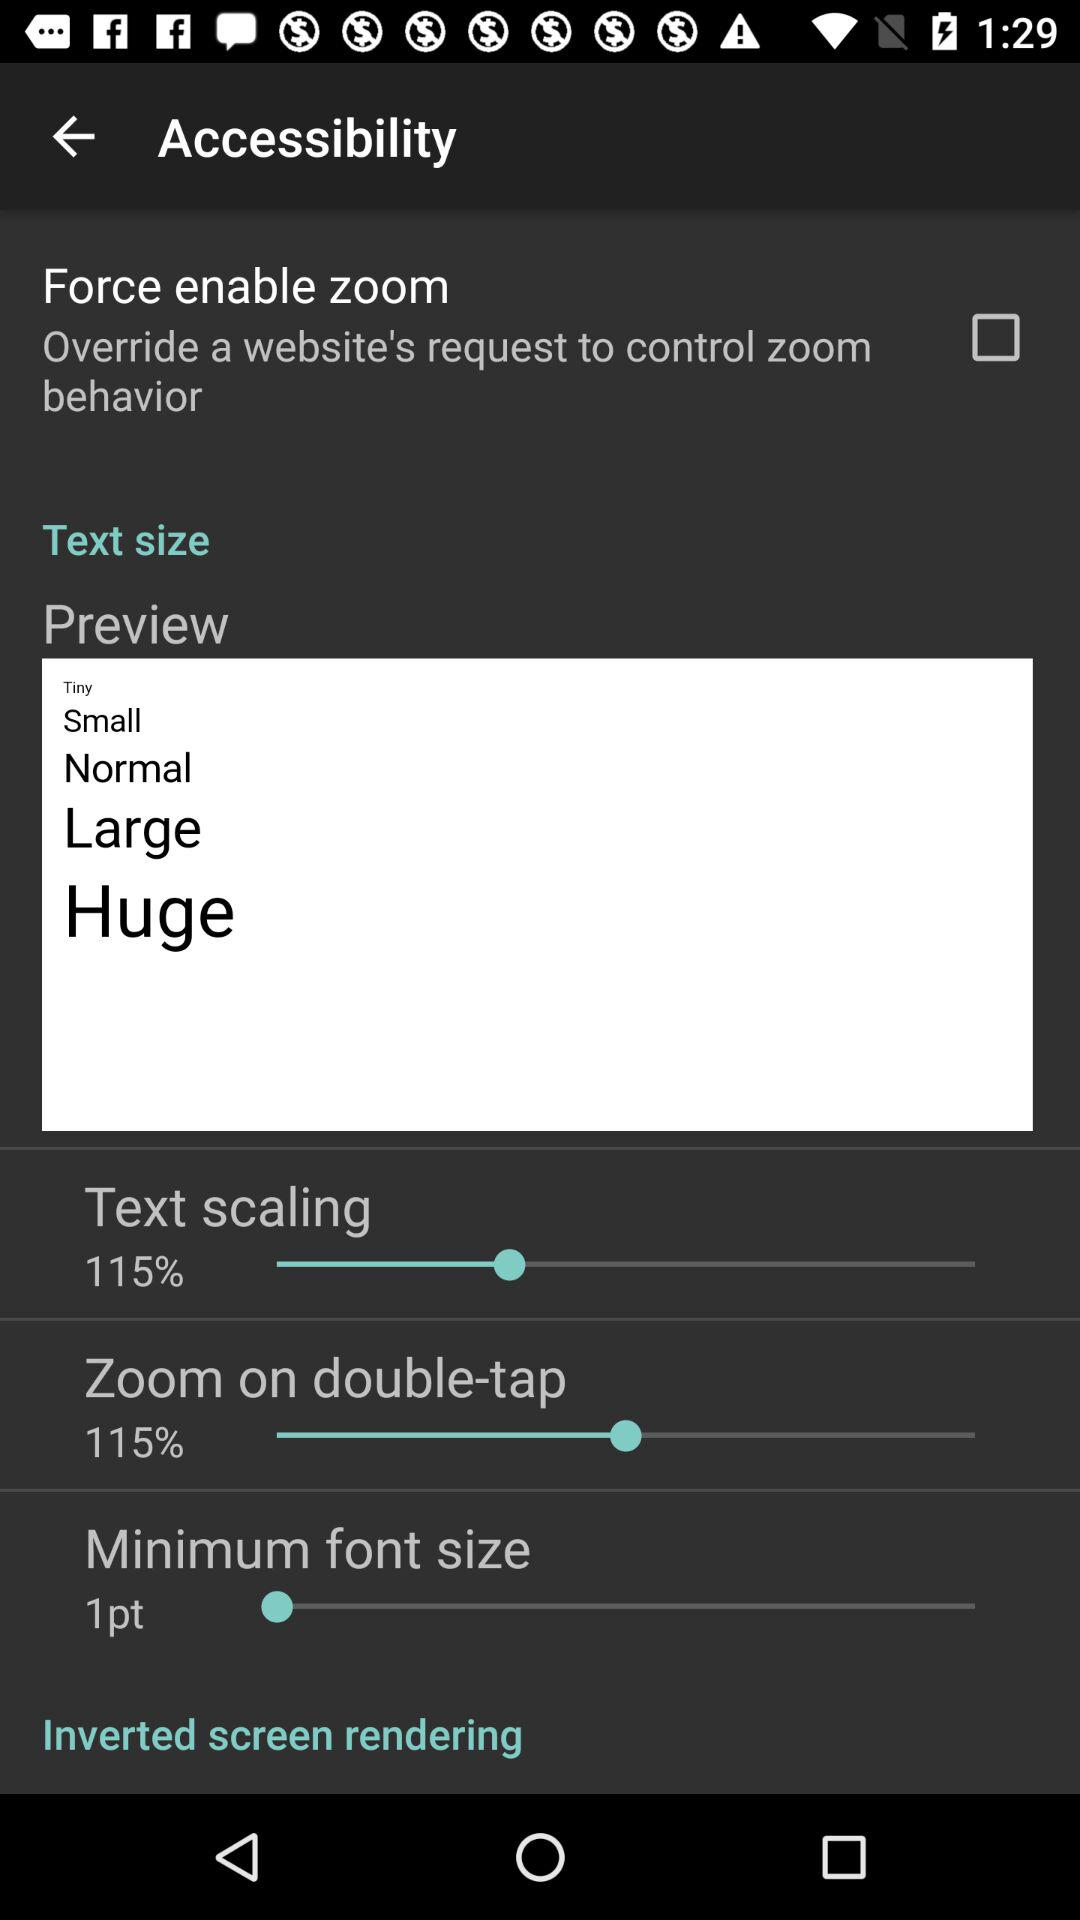What is the minimum font size? The minimum font size is 1 point. 